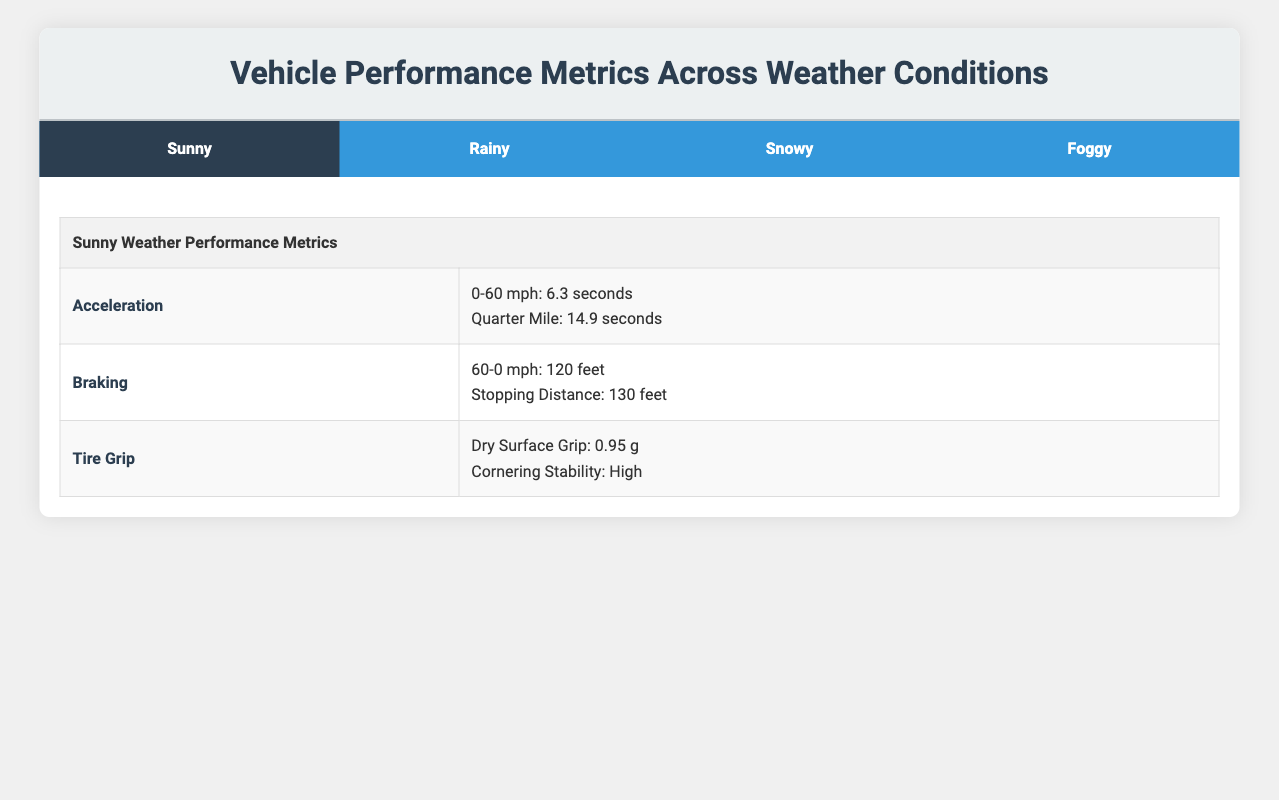What is the 0-60 mph acceleration time in rainy conditions? The table indicates that the acceleration metric for 0-60 mph in rainy conditions is 7.5 seconds.
Answer: 7.5 seconds What is the quarter mile time for the vehicle in snowy conditions? Looking at the snowy section of the table, the quarter mile time is provided as 18.9 seconds.
Answer: 18.9 seconds Is the cornering stability better on a dry surface compared to a wet surface? The table states that the cornering stability on a dry surface is high and on a wet surface it is moderate, implying that the dry surface offers better cornering stability.
Answer: Yes What is the difference in stopping distance between sunny and snowy weather? The stopping distance in sunny weather is 130 feet, and in snowy conditions, it is 220 feet. To find the difference, subtract: 220 - 130 = 90 feet.
Answer: 90 feet In which weather condition does the vehicle take the longest time to accelerate from 0-60 mph? By examining the 0-60 mph acceleration times, snowy weather has the longest time at 10.2 seconds, compared to 6.3 seconds (sunny), 7.5 seconds (rainy), and 7.0 seconds (foggy).
Answer: Snowy What is the average wet surface grip across rainy and foggy conditions? The wet surface grip is 0.75 g in rainy conditions and is not explicitly stated for foggy conditions; however, reduced visibility impact for foggy weather does indicate a moderate grip, but a specific numerical value is not given. Therefore, we cannot calculate the average without a specific numerical value for foggy conditions.
Answer: Not calculable Does the stopping distance increase with worse weather conditions, based on the table? Analyzing the stopping distances, we see that they increase from sunny (130 feet) to rainy (160 feet) and then substantially to snowy (220 feet). This trend shows that as weather conditions worsen, stopping distances do increase.
Answer: Yes What is the difference in the dry surface grip between sunny and snowy weather? The dry surface grip is given as 0.95 g for sunny weather, while for snowy weather, it is not applicable as it is specifically stated as snow surface grip (0.40 g). Since these metrics apply in different contexts, there's no direct comparison possible.
Answer: Not applicable Is the quarter mile time longer in foggy conditions than in rainy conditions? The table shows that the quarter mile time in foggy conditions is 15.8 seconds, while in rainy conditions it is 16.2 seconds. Therefore, the foggy condition has a shorter quarter mile time.
Answer: No 